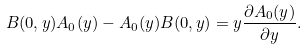Convert formula to latex. <formula><loc_0><loc_0><loc_500><loc_500>B ( 0 , y ) A _ { 0 } ( y ) - A _ { 0 } ( y ) B ( 0 , y ) = y \frac { \partial A _ { 0 } ( y ) } { \partial y } .</formula> 